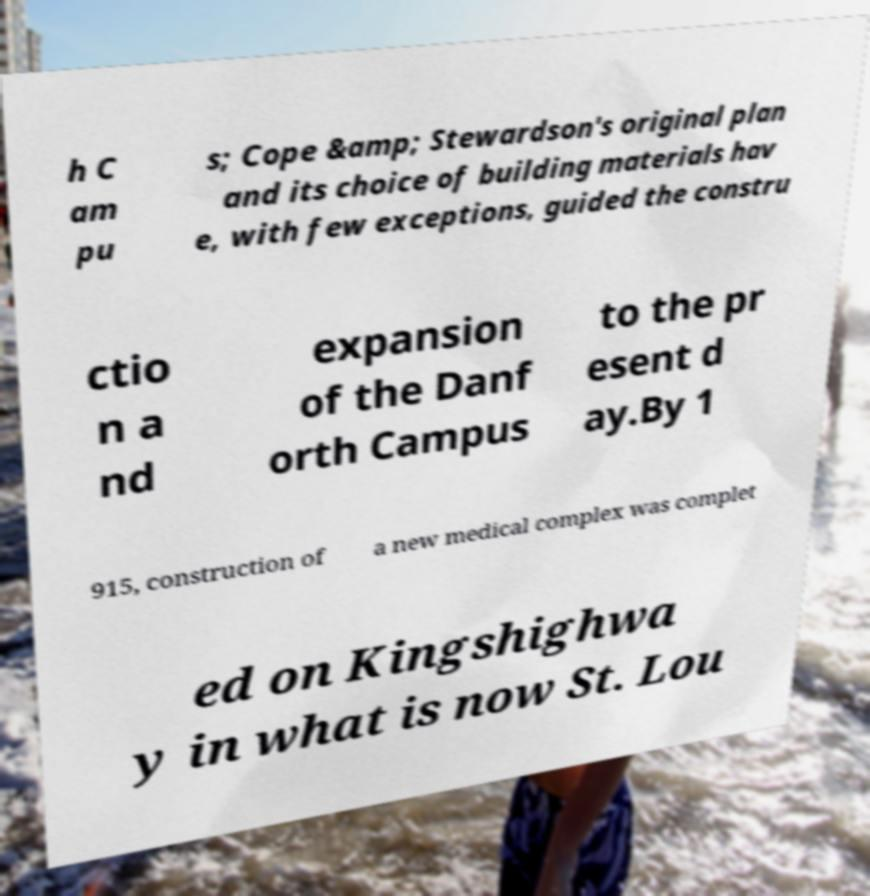Please read and relay the text visible in this image. What does it say? h C am pu s; Cope &amp; Stewardson's original plan and its choice of building materials hav e, with few exceptions, guided the constru ctio n a nd expansion of the Danf orth Campus to the pr esent d ay.By 1 915, construction of a new medical complex was complet ed on Kingshighwa y in what is now St. Lou 